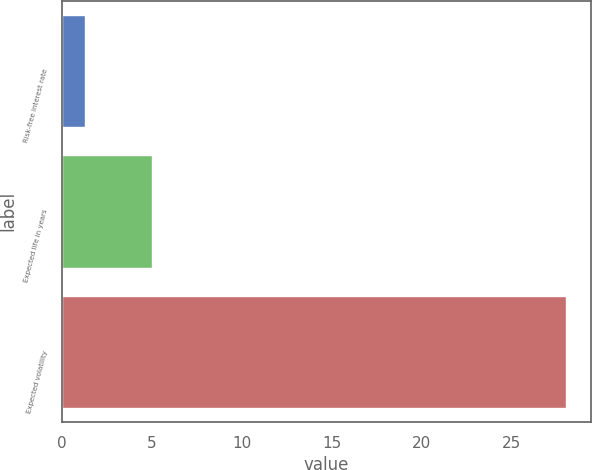<chart> <loc_0><loc_0><loc_500><loc_500><bar_chart><fcel>Risk-free interest rate<fcel>Expected life in years<fcel>Expected volatility<nl><fcel>1.31<fcel>5<fcel>28<nl></chart> 